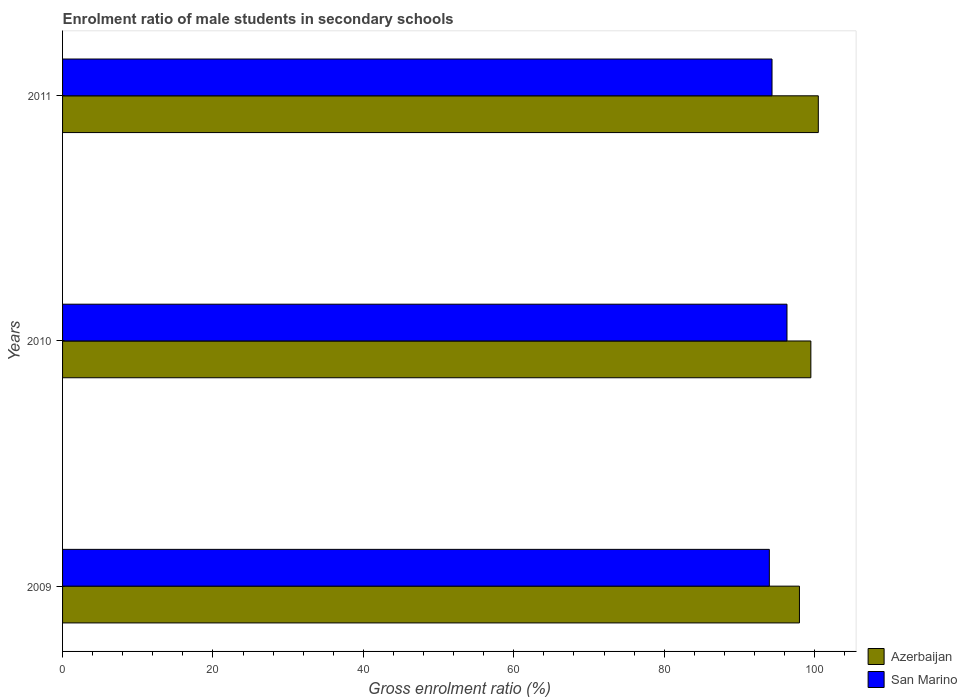How many groups of bars are there?
Provide a short and direct response. 3. Are the number of bars on each tick of the Y-axis equal?
Ensure brevity in your answer.  Yes. How many bars are there on the 2nd tick from the top?
Offer a terse response. 2. What is the label of the 2nd group of bars from the top?
Offer a very short reply. 2010. What is the enrolment ratio of male students in secondary schools in Azerbaijan in 2011?
Provide a succinct answer. 100.5. Across all years, what is the maximum enrolment ratio of male students in secondary schools in San Marino?
Offer a very short reply. 96.33. Across all years, what is the minimum enrolment ratio of male students in secondary schools in San Marino?
Ensure brevity in your answer.  93.99. What is the total enrolment ratio of male students in secondary schools in Azerbaijan in the graph?
Offer a terse response. 298. What is the difference between the enrolment ratio of male students in secondary schools in Azerbaijan in 2010 and that in 2011?
Provide a short and direct response. -0.99. What is the difference between the enrolment ratio of male students in secondary schools in Azerbaijan in 2009 and the enrolment ratio of male students in secondary schools in San Marino in 2011?
Offer a very short reply. 3.65. What is the average enrolment ratio of male students in secondary schools in Azerbaijan per year?
Keep it short and to the point. 99.33. In the year 2009, what is the difference between the enrolment ratio of male students in secondary schools in Azerbaijan and enrolment ratio of male students in secondary schools in San Marino?
Give a very brief answer. 4. What is the ratio of the enrolment ratio of male students in secondary schools in San Marino in 2009 to that in 2011?
Ensure brevity in your answer.  1. What is the difference between the highest and the second highest enrolment ratio of male students in secondary schools in Azerbaijan?
Provide a short and direct response. 0.99. What is the difference between the highest and the lowest enrolment ratio of male students in secondary schools in San Marino?
Your response must be concise. 2.35. In how many years, is the enrolment ratio of male students in secondary schools in San Marino greater than the average enrolment ratio of male students in secondary schools in San Marino taken over all years?
Provide a short and direct response. 1. Is the sum of the enrolment ratio of male students in secondary schools in Azerbaijan in 2009 and 2011 greater than the maximum enrolment ratio of male students in secondary schools in San Marino across all years?
Provide a short and direct response. Yes. What does the 2nd bar from the top in 2011 represents?
Your response must be concise. Azerbaijan. What does the 2nd bar from the bottom in 2009 represents?
Keep it short and to the point. San Marino. What is the difference between two consecutive major ticks on the X-axis?
Provide a short and direct response. 20. Does the graph contain any zero values?
Make the answer very short. No. How many legend labels are there?
Your response must be concise. 2. What is the title of the graph?
Provide a succinct answer. Enrolment ratio of male students in secondary schools. Does "Uruguay" appear as one of the legend labels in the graph?
Offer a terse response. No. What is the label or title of the Y-axis?
Provide a short and direct response. Years. What is the Gross enrolment ratio (%) of Azerbaijan in 2009?
Your response must be concise. 97.99. What is the Gross enrolment ratio (%) of San Marino in 2009?
Provide a short and direct response. 93.99. What is the Gross enrolment ratio (%) in Azerbaijan in 2010?
Provide a short and direct response. 99.51. What is the Gross enrolment ratio (%) in San Marino in 2010?
Provide a short and direct response. 96.33. What is the Gross enrolment ratio (%) in Azerbaijan in 2011?
Offer a terse response. 100.5. What is the Gross enrolment ratio (%) of San Marino in 2011?
Ensure brevity in your answer.  94.34. Across all years, what is the maximum Gross enrolment ratio (%) of Azerbaijan?
Provide a succinct answer. 100.5. Across all years, what is the maximum Gross enrolment ratio (%) in San Marino?
Provide a short and direct response. 96.33. Across all years, what is the minimum Gross enrolment ratio (%) of Azerbaijan?
Your answer should be very brief. 97.99. Across all years, what is the minimum Gross enrolment ratio (%) in San Marino?
Give a very brief answer. 93.99. What is the total Gross enrolment ratio (%) in Azerbaijan in the graph?
Provide a succinct answer. 298. What is the total Gross enrolment ratio (%) of San Marino in the graph?
Provide a short and direct response. 284.66. What is the difference between the Gross enrolment ratio (%) of Azerbaijan in 2009 and that in 2010?
Make the answer very short. -1.52. What is the difference between the Gross enrolment ratio (%) of San Marino in 2009 and that in 2010?
Ensure brevity in your answer.  -2.35. What is the difference between the Gross enrolment ratio (%) in Azerbaijan in 2009 and that in 2011?
Provide a short and direct response. -2.51. What is the difference between the Gross enrolment ratio (%) of San Marino in 2009 and that in 2011?
Your answer should be compact. -0.36. What is the difference between the Gross enrolment ratio (%) in Azerbaijan in 2010 and that in 2011?
Your answer should be very brief. -0.99. What is the difference between the Gross enrolment ratio (%) of San Marino in 2010 and that in 2011?
Ensure brevity in your answer.  1.99. What is the difference between the Gross enrolment ratio (%) in Azerbaijan in 2009 and the Gross enrolment ratio (%) in San Marino in 2010?
Your answer should be very brief. 1.66. What is the difference between the Gross enrolment ratio (%) in Azerbaijan in 2009 and the Gross enrolment ratio (%) in San Marino in 2011?
Your response must be concise. 3.65. What is the difference between the Gross enrolment ratio (%) of Azerbaijan in 2010 and the Gross enrolment ratio (%) of San Marino in 2011?
Keep it short and to the point. 5.17. What is the average Gross enrolment ratio (%) in Azerbaijan per year?
Give a very brief answer. 99.33. What is the average Gross enrolment ratio (%) of San Marino per year?
Provide a succinct answer. 94.89. In the year 2009, what is the difference between the Gross enrolment ratio (%) of Azerbaijan and Gross enrolment ratio (%) of San Marino?
Provide a short and direct response. 4. In the year 2010, what is the difference between the Gross enrolment ratio (%) in Azerbaijan and Gross enrolment ratio (%) in San Marino?
Offer a very short reply. 3.18. In the year 2011, what is the difference between the Gross enrolment ratio (%) of Azerbaijan and Gross enrolment ratio (%) of San Marino?
Keep it short and to the point. 6.16. What is the ratio of the Gross enrolment ratio (%) of Azerbaijan in 2009 to that in 2010?
Your answer should be very brief. 0.98. What is the ratio of the Gross enrolment ratio (%) in San Marino in 2009 to that in 2010?
Give a very brief answer. 0.98. What is the ratio of the Gross enrolment ratio (%) of San Marino in 2009 to that in 2011?
Your answer should be compact. 1. What is the ratio of the Gross enrolment ratio (%) in Azerbaijan in 2010 to that in 2011?
Keep it short and to the point. 0.99. What is the ratio of the Gross enrolment ratio (%) in San Marino in 2010 to that in 2011?
Offer a very short reply. 1.02. What is the difference between the highest and the second highest Gross enrolment ratio (%) in Azerbaijan?
Your answer should be compact. 0.99. What is the difference between the highest and the second highest Gross enrolment ratio (%) in San Marino?
Provide a succinct answer. 1.99. What is the difference between the highest and the lowest Gross enrolment ratio (%) in Azerbaijan?
Keep it short and to the point. 2.51. What is the difference between the highest and the lowest Gross enrolment ratio (%) in San Marino?
Offer a very short reply. 2.35. 